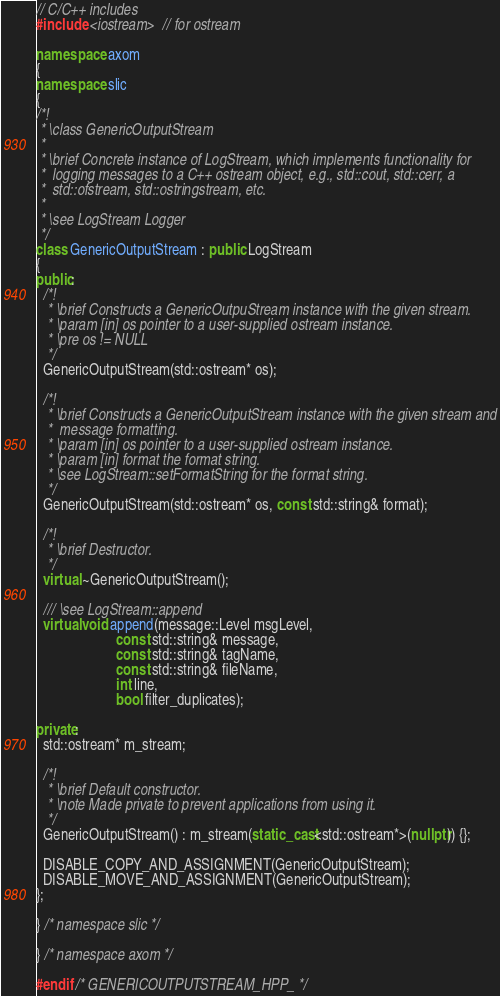<code> <loc_0><loc_0><loc_500><loc_500><_C++_>// C/C++ includes
#include <iostream>  // for ostream

namespace axom
{
namespace slic
{
/*!
 * \class GenericOutputStream
 *
 * \brief Concrete instance of LogStream, which implements functionality for
 *  logging messages to a C++ ostream object, e.g., std::cout, std::cerr, a
 *  std::ofstream, std::ostringstream, etc.
 *
 * \see LogStream Logger
 */
class GenericOutputStream : public LogStream
{
public:
  /*!
   * \brief Constructs a GenericOutpuStream instance with the given stream.
   * \param [in] os pointer to a user-supplied ostream instance.
   * \pre os != NULL
   */
  GenericOutputStream(std::ostream* os);

  /*!
   * \brief Constructs a GenericOutputStream instance with the given stream and
   *  message formatting.
   * \param [in] os pointer to a user-supplied ostream instance.
   * \param [in] format the format string.
   * \see LogStream::setFormatString for the format string.
   */
  GenericOutputStream(std::ostream* os, const std::string& format);

  /*!
   * \brief Destructor.
   */
  virtual ~GenericOutputStream();

  /// \see LogStream::append
  virtual void append(message::Level msgLevel,
                      const std::string& message,
                      const std::string& tagName,
                      const std::string& fileName,
                      int line,
                      bool filter_duplicates);

private:
  std::ostream* m_stream;

  /*!
   * \brief Default constructor.
   * \note Made private to prevent applications from using it.
   */
  GenericOutputStream() : m_stream(static_cast<std::ostream*>(nullptr)) {};

  DISABLE_COPY_AND_ASSIGNMENT(GenericOutputStream);
  DISABLE_MOVE_AND_ASSIGNMENT(GenericOutputStream);
};

} /* namespace slic */

} /* namespace axom */

#endif /* GENERICOUTPUTSTREAM_HPP_ */
</code> 